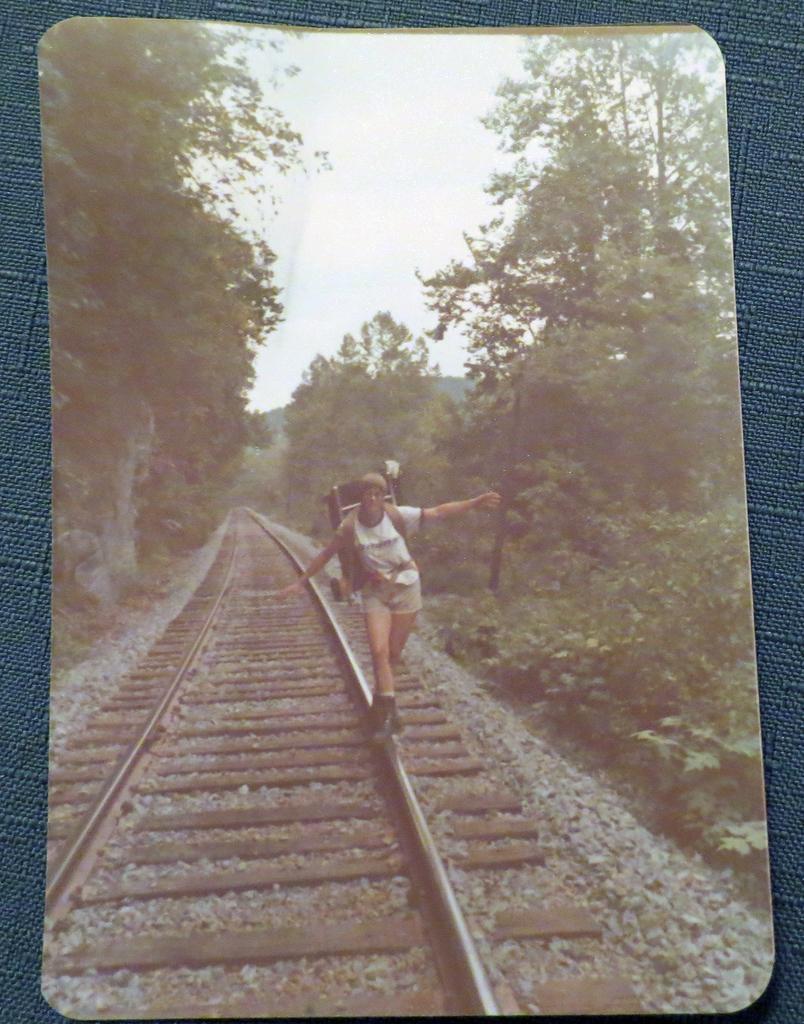Can you describe this image briefly? In this image I can see a photograph of a person standing on a railway track. There are trees on the either sides and there is sky at the top. 